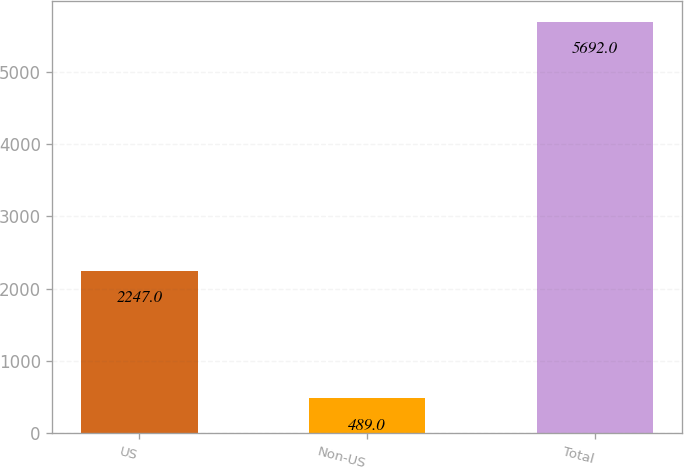<chart> <loc_0><loc_0><loc_500><loc_500><bar_chart><fcel>US<fcel>Non-US<fcel>Total<nl><fcel>2247<fcel>489<fcel>5692<nl></chart> 